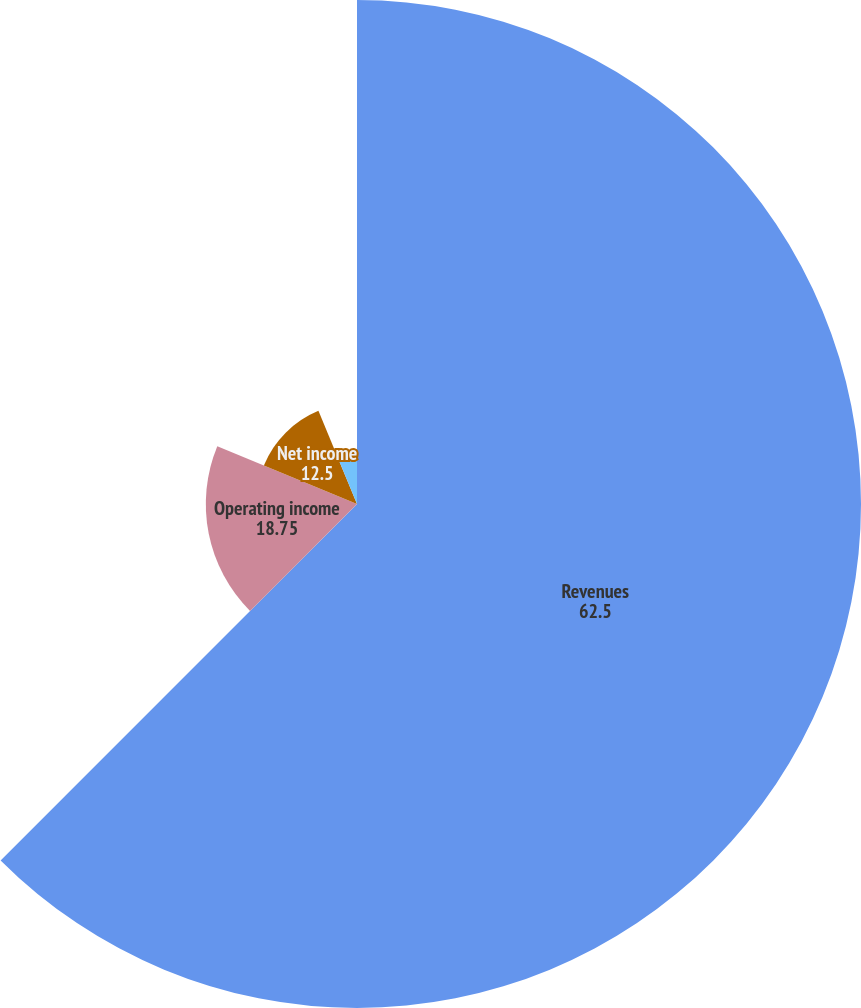Convert chart. <chart><loc_0><loc_0><loc_500><loc_500><pie_chart><fcel>Revenues<fcel>Operating income<fcel>Net income<fcel>Basic<fcel>Diluted<nl><fcel>62.5%<fcel>18.75%<fcel>12.5%<fcel>6.25%<fcel>0.0%<nl></chart> 